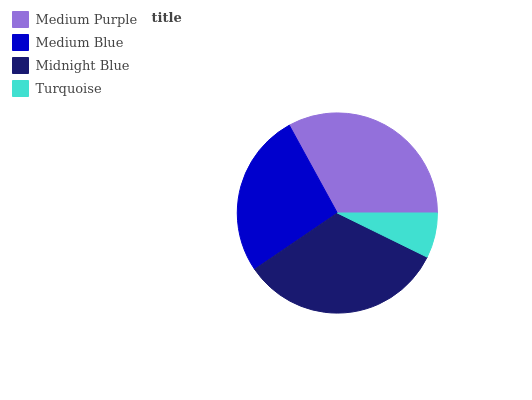Is Turquoise the minimum?
Answer yes or no. Yes. Is Midnight Blue the maximum?
Answer yes or no. Yes. Is Medium Blue the minimum?
Answer yes or no. No. Is Medium Blue the maximum?
Answer yes or no. No. Is Medium Purple greater than Medium Blue?
Answer yes or no. Yes. Is Medium Blue less than Medium Purple?
Answer yes or no. Yes. Is Medium Blue greater than Medium Purple?
Answer yes or no. No. Is Medium Purple less than Medium Blue?
Answer yes or no. No. Is Medium Purple the high median?
Answer yes or no. Yes. Is Medium Blue the low median?
Answer yes or no. Yes. Is Turquoise the high median?
Answer yes or no. No. Is Medium Purple the low median?
Answer yes or no. No. 